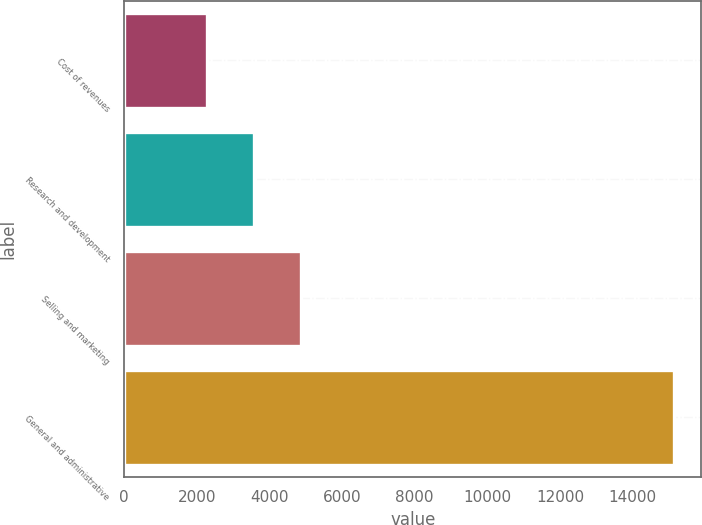Convert chart. <chart><loc_0><loc_0><loc_500><loc_500><bar_chart><fcel>Cost of revenues<fcel>Research and development<fcel>Selling and marketing<fcel>General and administrative<nl><fcel>2293<fcel>3577.4<fcel>4861.8<fcel>15137<nl></chart> 